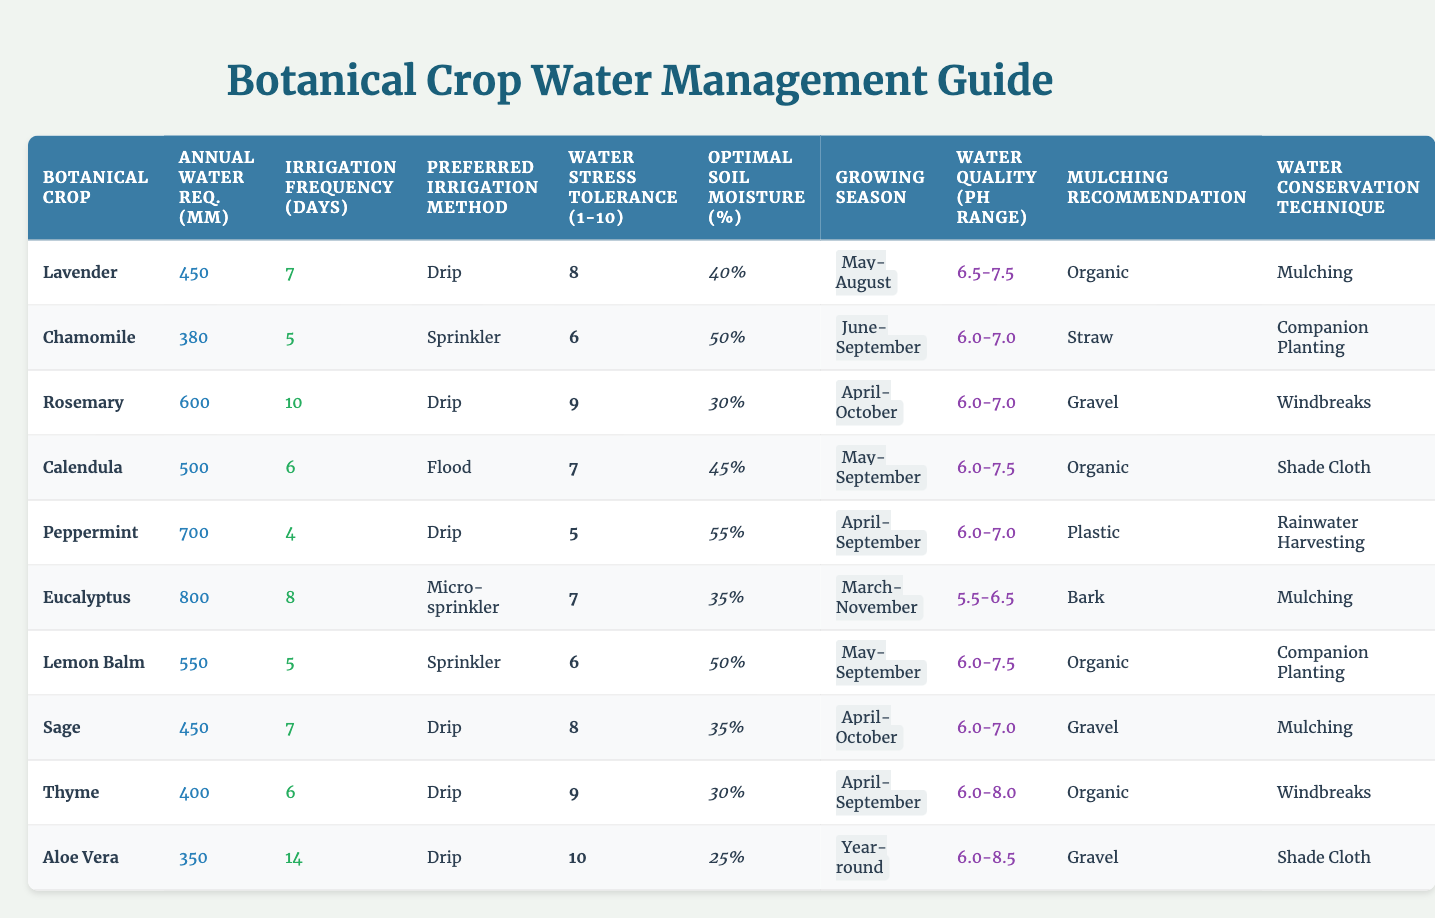What is the annual water requirement for Peppermint? The table shows that Peppermint has an annual water requirement of 700 mm.
Answer: 700 mm Which botanical crop has the highest water stress tolerance? By scanning the Water Stress Tolerance Scale in the table, Aloe Vera has the highest score of 10.
Answer: Aloe Vera How often should you irrigate Calendula? The table indicates Calendula should be irrigated every 6 days.
Answer: Every 6 days What is the optimal soil moisture percentage for Rosemary? The table lists the optimal soil moisture percentage for Rosemary as 30%.
Answer: 30% Which irrigation method is preferred for Eucalyptus? According to the table, Eucalyptus prefers the micro-sprinkler irrigation method.
Answer: Micro-sprinkler What is the average annual water requirement for the crops surveyed? Calculating the average: (450 + 380 + 600 + 500 + 700 + 800 + 550 + 450 + 400 + 350) / 10 = 486 mm.
Answer: 486 mm Does Chamomile have a lower irrigation frequency than Lavender? The table shows Chamomile has an irrigation frequency of 5 days, while Lavender has 7 days, so Chamomile does have a lower frequency.
Answer: Yes Which crop requires mulching, and what type is recommended? The table shows that Lavender, Calendula, Lemon Balm, Thyme, and Aloe Vera recommend organic, gravel, organic, organic, and gravel mulching, respectively.
Answer: Various types; example: Lavender - Organic What percentage of optimal soil moisture is needed for Peppermint? Peppermint requires an optimal soil moisture percentage of 55% as stated in the table.
Answer: 55% Which botanical crop has the longest growing season? Scanning through the Growing Season Months, Eucalyptus has a year-round growing season.
Answer: Year-round How much more water does Rosemary need compared to Sage? The difference in water requirement between Rosemary (600 mm) and Sage (450 mm) is 150 mm, meaning Rosemary needs more water.
Answer: 150 mm more Out of all botanical crops listed, which one has the lowest annual water requirement? By reviewing the Annual Water Requirement mm column, Aloe Vera has the lowest requirement of 350 mm.
Answer: 350 mm Is the irrigation frequency for Thyme equal to that of Calendula? The table shows Thyme has an irrigation frequency of 6 days while Calendula has 6 days as well, meaning they are equal.
Answer: Yes If you sum the water requirements of Lavender and Chamomile, what is the total? Adding the two requirements: Lavender (450 mm) + Chamomile (380 mm) = 830 mm, shows that combined they need 830 mm.
Answer: 830 mm What type of water conservation technique is suggested for Eucalyptus? The table indicates that Eucalyptus recommends using mulching as a water conservation technique.
Answer: Mulching Which crops recommend organic mulching, and how many are there? Lavender, Calendula, and Lemon Balm recommend organic mulching, totaling 3 crops.
Answer: 3 crops Is the recommended irrigation method for both Lavender and Rosemary the same? The table shows both crops prefer different irrigation methods; Lavender uses drip, while Rosemary uses drip as well, so they are the same.
Answer: Yes 